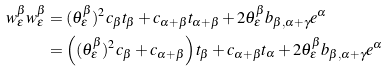<formula> <loc_0><loc_0><loc_500><loc_500>w ^ { \beta } _ { \epsilon } w ^ { \beta } _ { \epsilon } & = ( \theta ^ { \beta } _ { \epsilon } ) ^ { 2 } c _ { \beta } t _ { \beta } + c _ { \alpha + \beta } t _ { \alpha + \beta } + 2 \theta ^ { \beta } _ { \epsilon } b _ { \beta , \alpha + \gamma } e ^ { \alpha } \\ & = \left ( ( \theta ^ { \beta } _ { \epsilon } ) ^ { 2 } c _ { \beta } + c _ { \alpha + \beta } \right ) t _ { \beta } + c _ { \alpha + \beta } t _ { \alpha } + 2 \theta ^ { \beta } _ { \epsilon } b _ { \beta , \alpha + \gamma } e ^ { \alpha }</formula> 